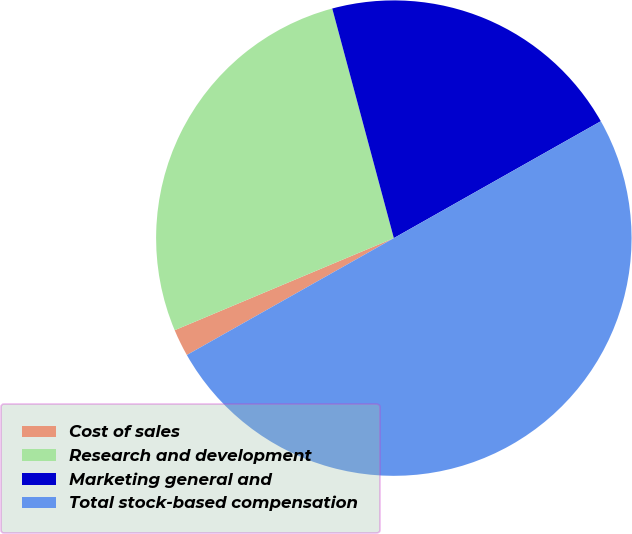Convert chart. <chart><loc_0><loc_0><loc_500><loc_500><pie_chart><fcel>Cost of sales<fcel>Research and development<fcel>Marketing general and<fcel>Total stock-based compensation<nl><fcel>1.85%<fcel>27.16%<fcel>20.99%<fcel>50.0%<nl></chart> 